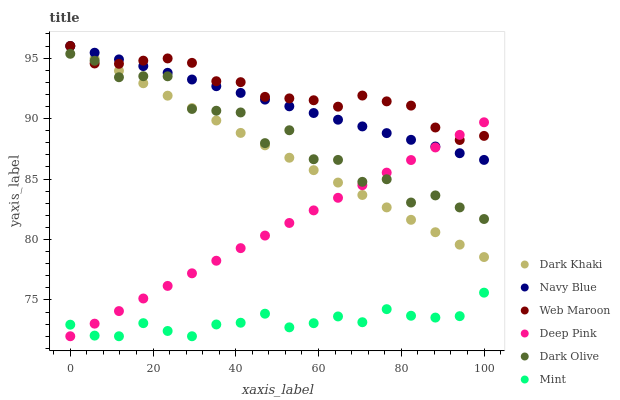Does Mint have the minimum area under the curve?
Answer yes or no. Yes. Does Web Maroon have the maximum area under the curve?
Answer yes or no. Yes. Does Navy Blue have the minimum area under the curve?
Answer yes or no. No. Does Navy Blue have the maximum area under the curve?
Answer yes or no. No. Is Deep Pink the smoothest?
Answer yes or no. Yes. Is Dark Olive the roughest?
Answer yes or no. Yes. Is Navy Blue the smoothest?
Answer yes or no. No. Is Navy Blue the roughest?
Answer yes or no. No. Does Deep Pink have the lowest value?
Answer yes or no. Yes. Does Navy Blue have the lowest value?
Answer yes or no. No. Does Dark Khaki have the highest value?
Answer yes or no. Yes. Does Dark Olive have the highest value?
Answer yes or no. No. Is Mint less than Dark Khaki?
Answer yes or no. Yes. Is Dark Olive greater than Mint?
Answer yes or no. Yes. Does Mint intersect Deep Pink?
Answer yes or no. Yes. Is Mint less than Deep Pink?
Answer yes or no. No. Is Mint greater than Deep Pink?
Answer yes or no. No. Does Mint intersect Dark Khaki?
Answer yes or no. No. 